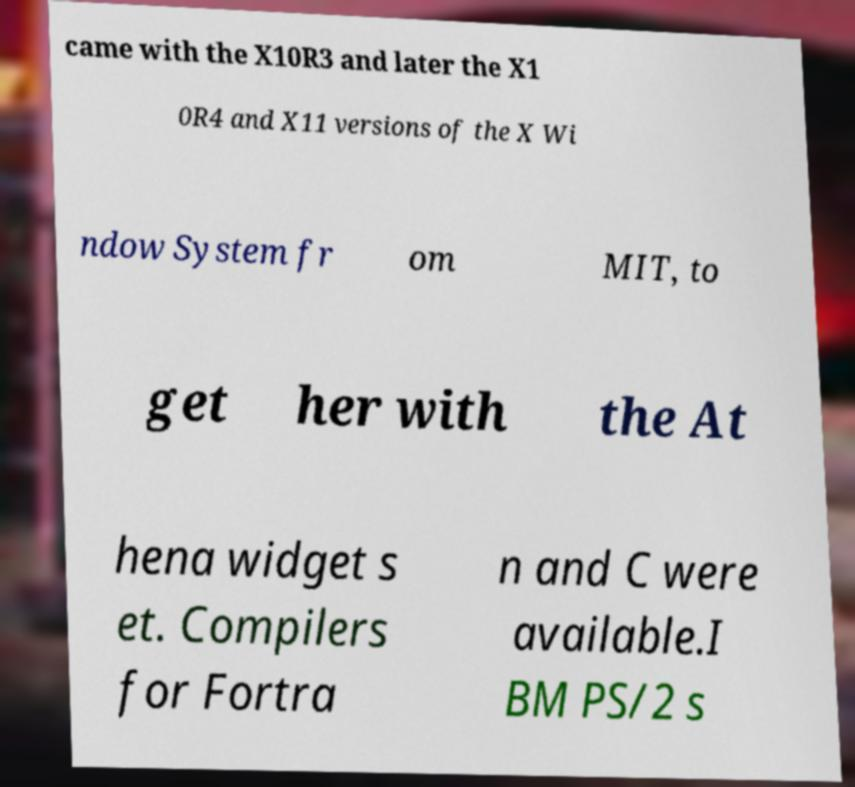I need the written content from this picture converted into text. Can you do that? came with the X10R3 and later the X1 0R4 and X11 versions of the X Wi ndow System fr om MIT, to get her with the At hena widget s et. Compilers for Fortra n and C were available.I BM PS/2 s 